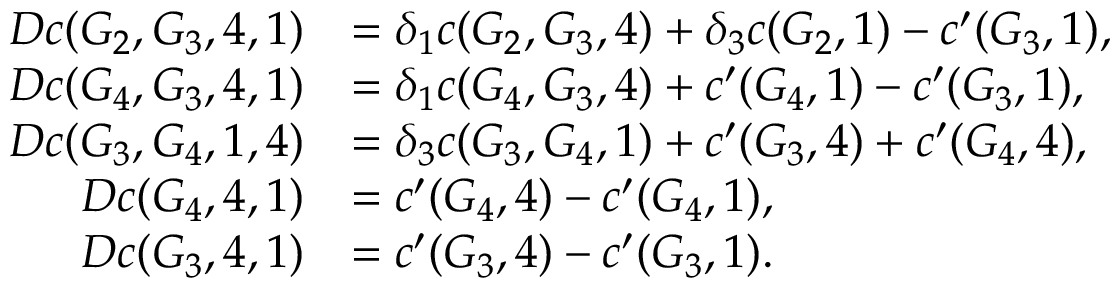Convert formula to latex. <formula><loc_0><loc_0><loc_500><loc_500>\begin{array} { r l } { D c ( G _ { 2 } , G _ { 3 } , 4 , 1 ) } & { = \delta _ { 1 } c ( G _ { 2 } , G _ { 3 } , 4 ) + \delta _ { 3 } c ( G _ { 2 } , 1 ) - c ^ { \prime } ( G _ { 3 } , 1 ) , } \\ { D c ( G _ { 4 } , G _ { 3 } , 4 , 1 ) } & { = \delta _ { 1 } c ( G _ { 4 } , G _ { 3 } , 4 ) + c ^ { \prime } ( G _ { 4 } , 1 ) - c ^ { \prime } ( G _ { 3 } , 1 ) , } \\ { D c ( G _ { 3 } , G _ { 4 } , 1 , 4 ) } & { = \delta _ { 3 } c ( G _ { 3 } , G _ { 4 } , 1 ) + c ^ { \prime } ( G _ { 3 } , 4 ) + c ^ { \prime } ( G _ { 4 } , 4 ) , } \\ { D c ( G _ { 4 } , 4 , 1 ) } & { = c ^ { \prime } ( G _ { 4 } , 4 ) - c ^ { \prime } ( G _ { 4 } , 1 ) , } \\ { D c ( G _ { 3 } , 4 , 1 ) } & { = c ^ { \prime } ( G _ { 3 } , 4 ) - c ^ { \prime } ( G _ { 3 } , 1 ) . } \end{array}</formula> 